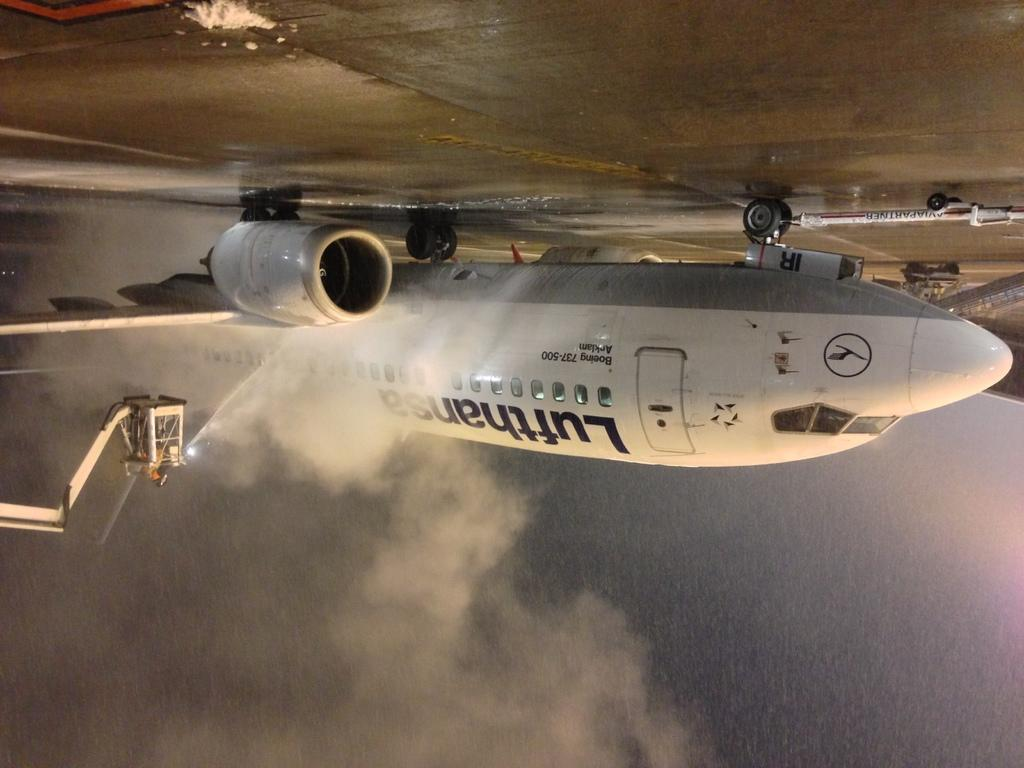<image>
Give a short and clear explanation of the subsequent image. a photo of an upside down plane with Lufthanser on the side. 